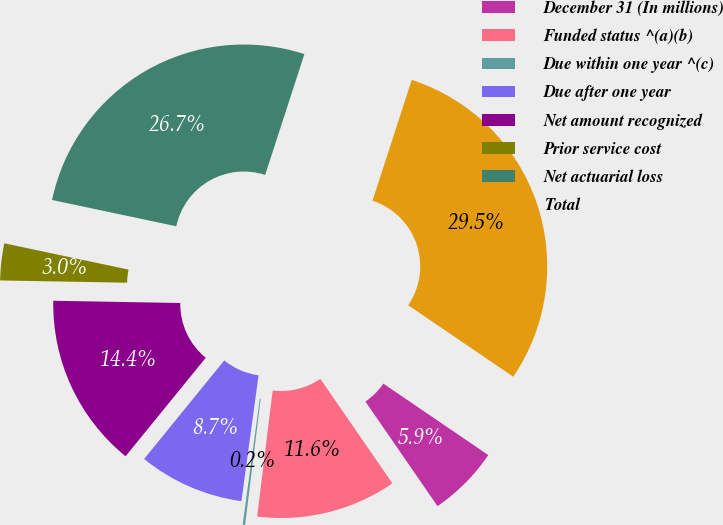Convert chart. <chart><loc_0><loc_0><loc_500><loc_500><pie_chart><fcel>December 31 (In millions)<fcel>Funded status ^(a)(b)<fcel>Due within one year ^(c)<fcel>Due after one year<fcel>Net amount recognized<fcel>Prior service cost<fcel>Net actuarial loss<fcel>Total<nl><fcel>5.88%<fcel>11.56%<fcel>0.2%<fcel>8.72%<fcel>14.41%<fcel>3.04%<fcel>26.68%<fcel>29.52%<nl></chart> 